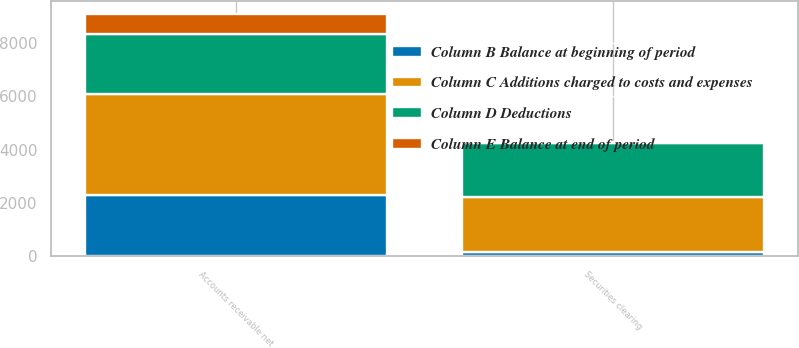Convert chart to OTSL. <chart><loc_0><loc_0><loc_500><loc_500><stacked_bar_chart><ecel><fcel>Accounts receivable net<fcel>Securities clearing<nl><fcel>Column C Additions charged to costs and expenses<fcel>3796<fcel>2096<nl><fcel>Column E Balance at end of period<fcel>754<fcel>52<nl><fcel>Column B Balance at beginning of period<fcel>2299<fcel>148<nl><fcel>Column D Deductions<fcel>2251<fcel>2000<nl></chart> 